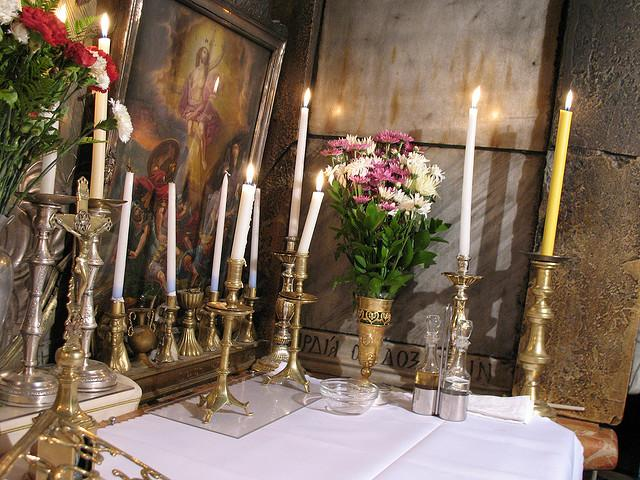What state are the candles in? Please explain your reasoning. lit. Most of them have a small fire lit on each of their tops which is fueled by a wick coming from inside each candle. 